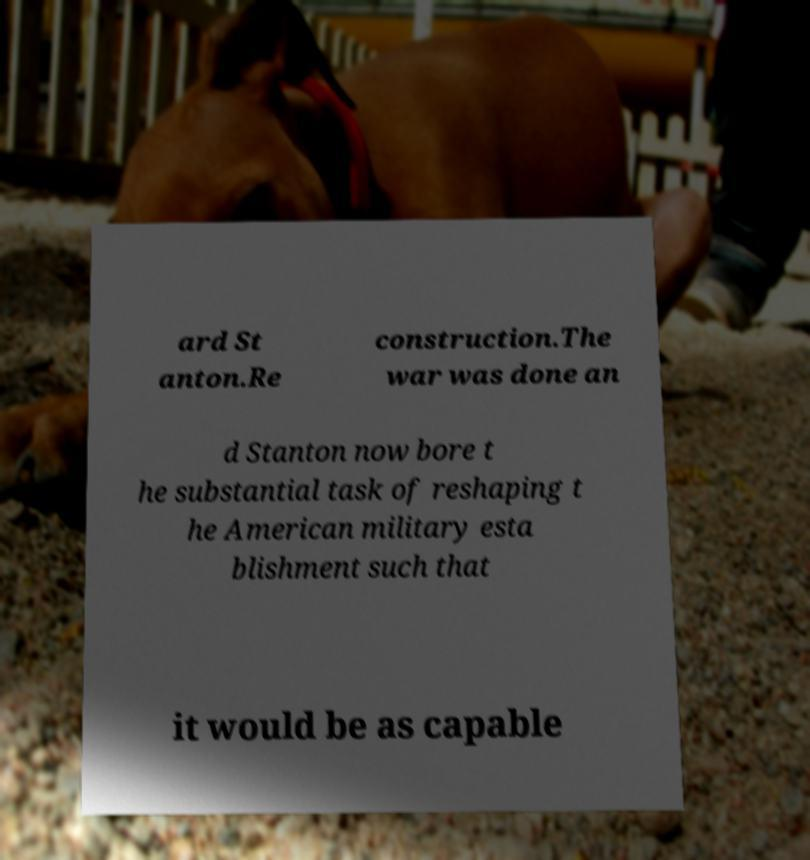Could you assist in decoding the text presented in this image and type it out clearly? ard St anton.Re construction.The war was done an d Stanton now bore t he substantial task of reshaping t he American military esta blishment such that it would be as capable 